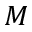Convert formula to latex. <formula><loc_0><loc_0><loc_500><loc_500>M</formula> 